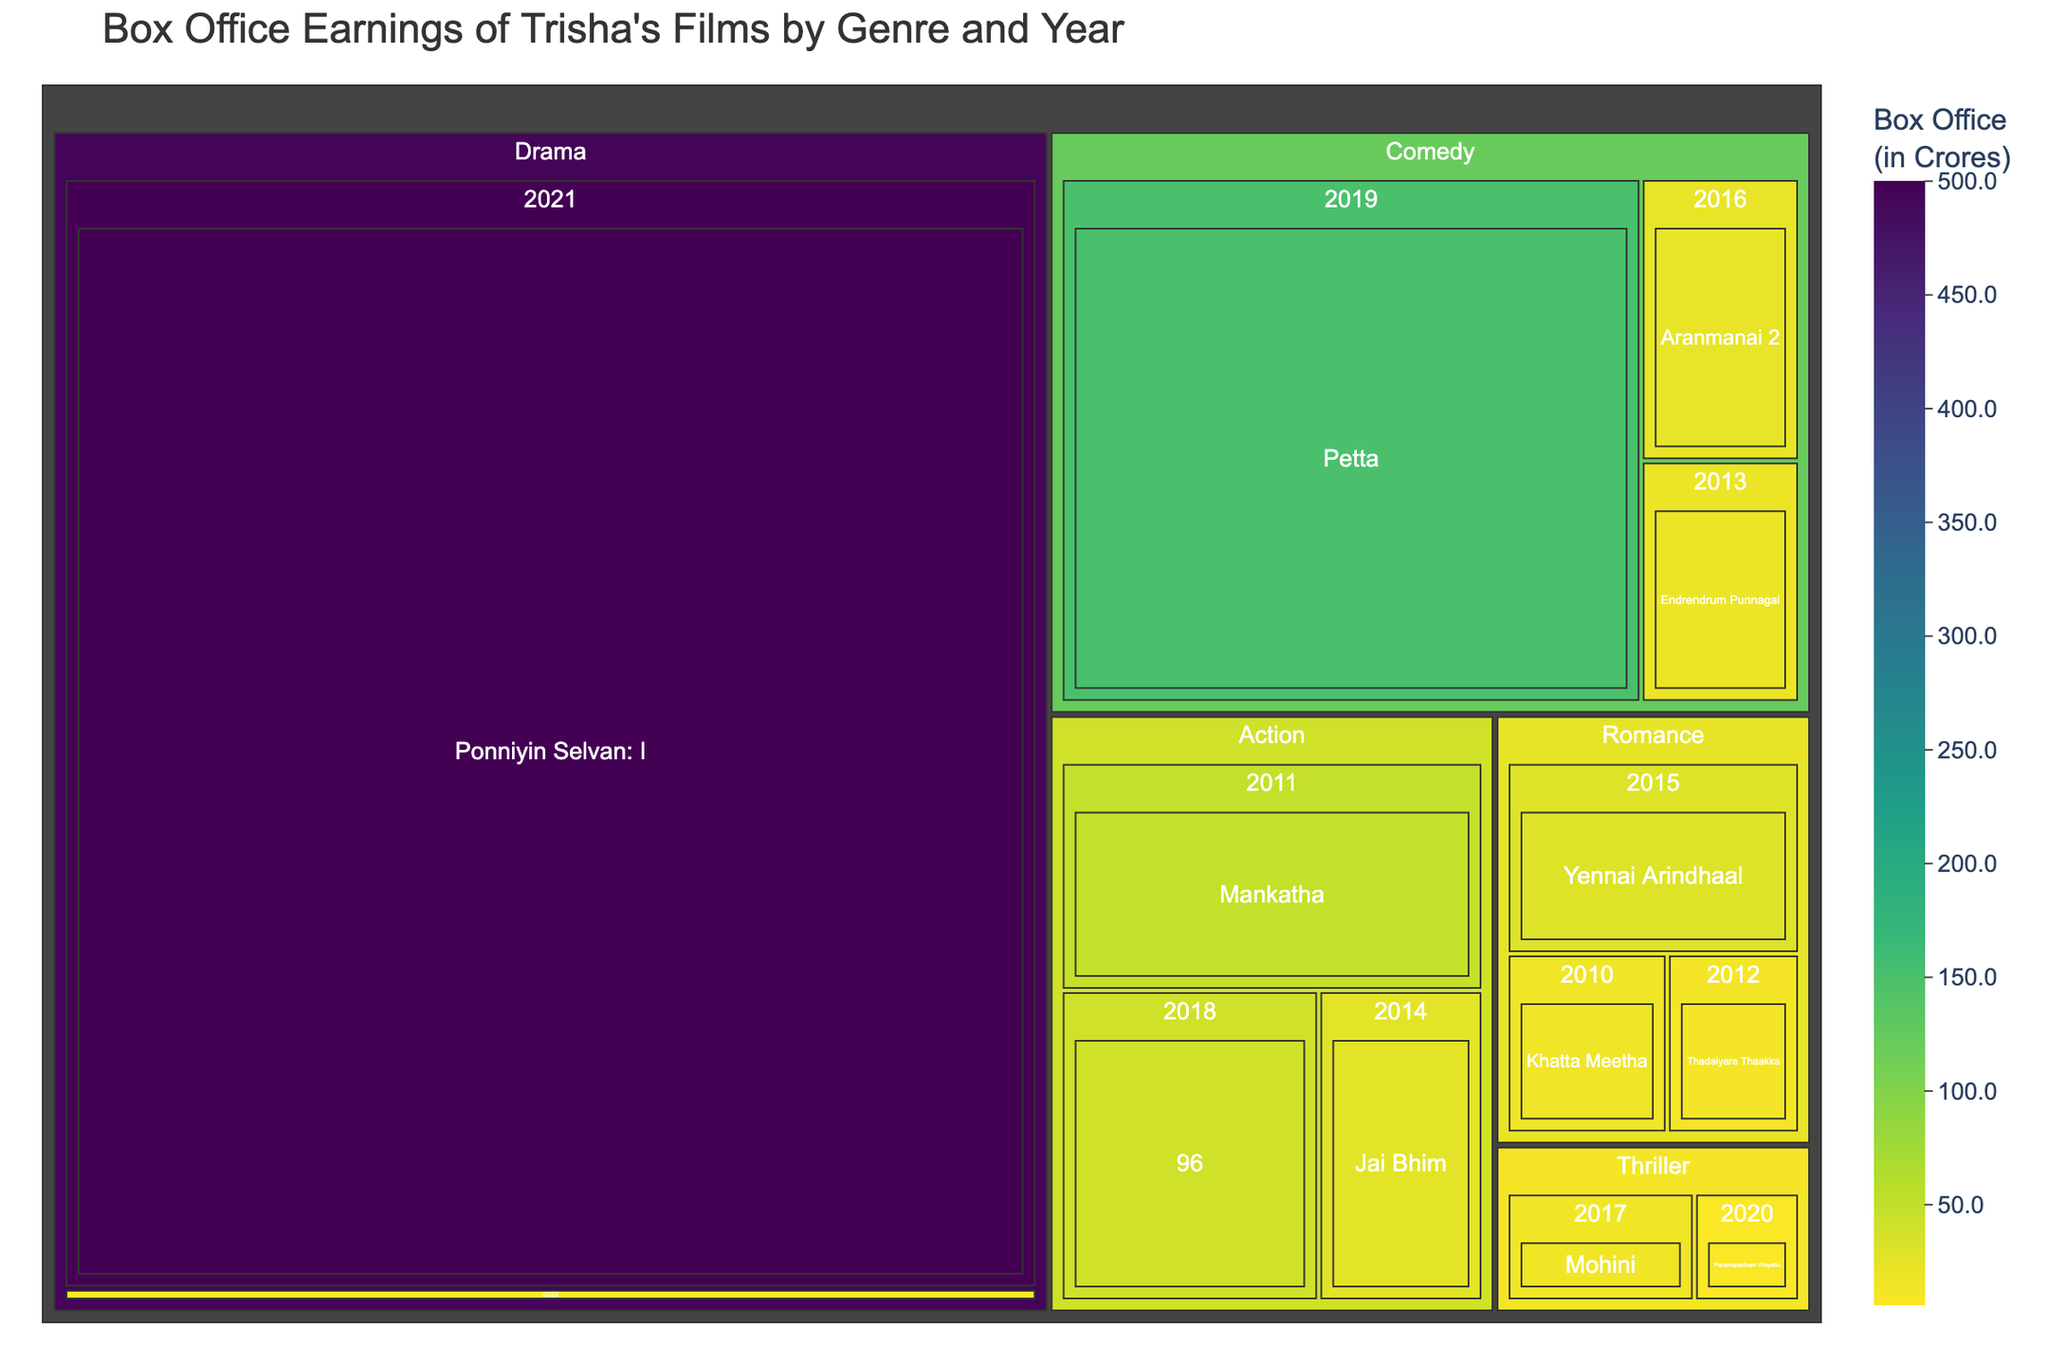What's the title of the figure? The title is usually displayed at the top of the figure. Here it says "Box Office Earnings of Trisha's Films by Genre and Year".
Answer: Box Office Earnings of Trisha's Films by Genre and Year Which movie generated the highest box office earnings? To find this, we look for the largest box in the treemap, which represents the highest earnings. The largest box corresponds to "Ponniyin Selvan: I" in the Drama genre.
Answer: Ponniyin Selvan: I How many genres are represented in the treemap? The treemap segments each genre, so by counting the distinct top-level divisions, we can find the number of genres. There are 5 genres: Romance, Action, Comedy, Thriller, and Drama.
Answer: 5 Which genre has the highest total box office earnings? Summing the box office earnings of movies within each genre, the Drama genre stands out because "Ponniyin Selvan: I" alone has very high earnings.
Answer: Drama What is the sum of box office earnings for movies released in 2019? We identify all movies from 2019 and sum their earnings. The only movie is "Petta" with ₹150.0 Crores.
Answer: ₹150.0 Crores Between the Romance and Thriller genres, which one has a higher total box office earnings? We sum the earnings for each genre: Romance (15.5 + 12.8 + 30.2 = 58.5) and Thriller (14.6 + 8.2 = 22.8). Comparing these, Romance has higher earnings.
Answer: Romance How much did the movie "Aranmanai 2" earn at the box office? Locate "Aranmanai 2" on the treemap under the Comedy genre and hover or refer to the corresponding value. It earned ₹22.1 Crores.
Answer: ₹22.1 Crores Which year has the lowest box office earnings overall? Calculate the total earnings for each year and find the smallest sum. The year 2022 with only "The Road" at ₹5.8 Crores has the lowest earnings.
Answer: 2022 What is the average box office earnings for the Action genre? We sum the earnings of all Action movies (48.5 + 25.7 + 40.3 = 114.5) and divide by the number of movies (3). The average is 114.5 / 3 ≈ 38.2 Crores.
Answer: ₹38.2 Crores Which genre has the fewest movies represented in the treemap? Count the number of movies in each genre. Drama and Thriller both have 2 movies each, which is the fewest.
Answer: Drama and Thriller 